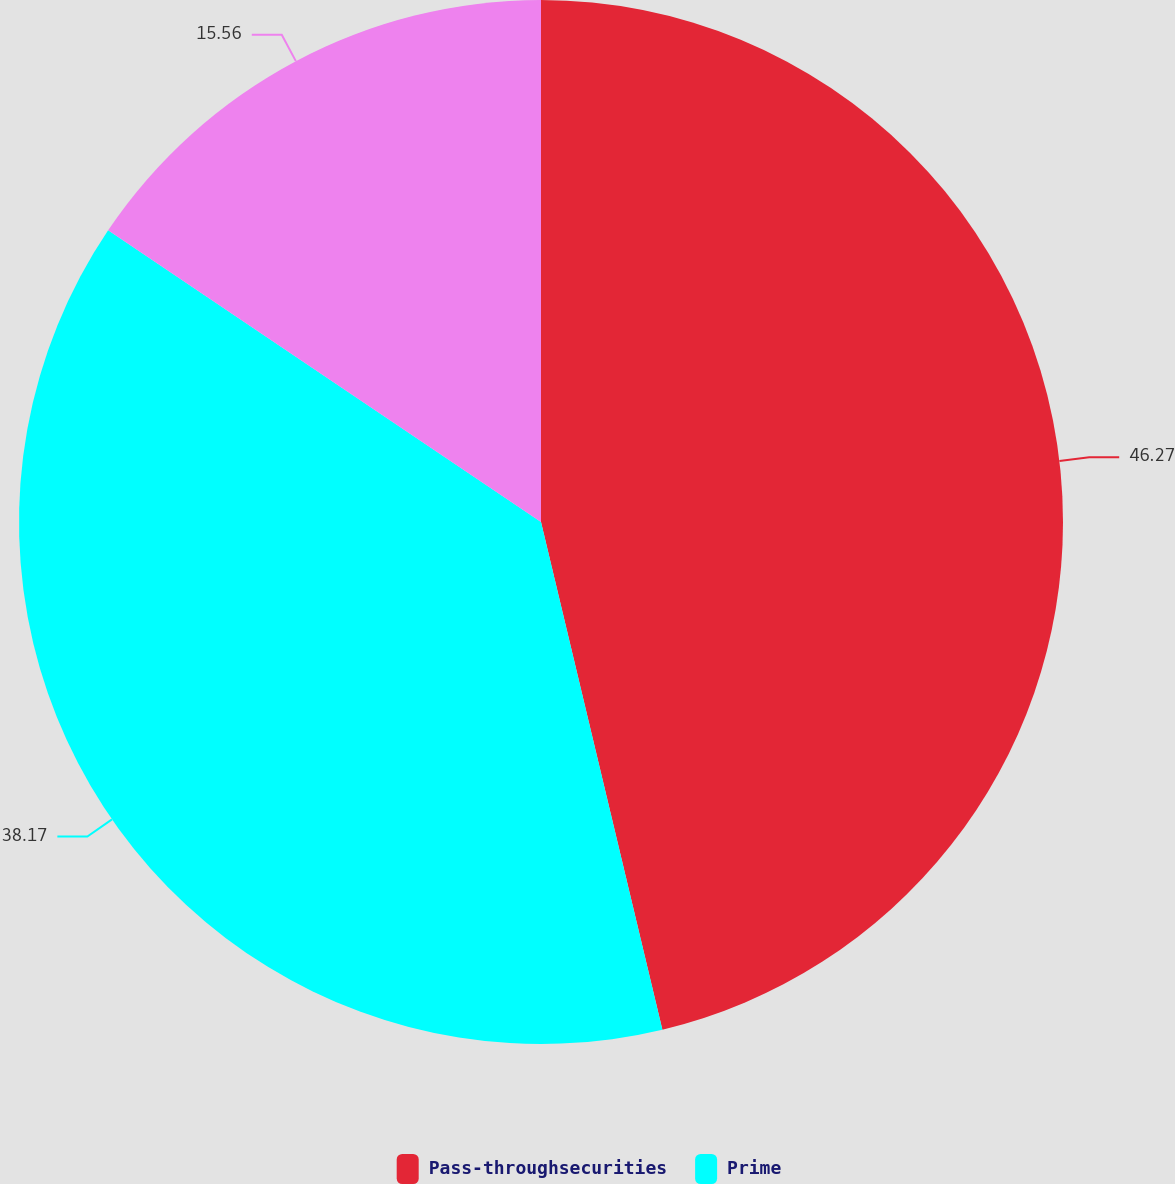Convert chart to OTSL. <chart><loc_0><loc_0><loc_500><loc_500><pie_chart><fcel>Pass-throughsecurities<fcel>Prime<fcel>Unnamed: 2<nl><fcel>46.26%<fcel>38.17%<fcel>15.56%<nl></chart> 